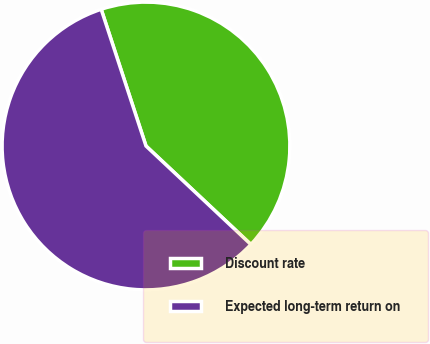<chart> <loc_0><loc_0><loc_500><loc_500><pie_chart><fcel>Discount rate<fcel>Expected long-term return on<nl><fcel>42.04%<fcel>57.96%<nl></chart> 